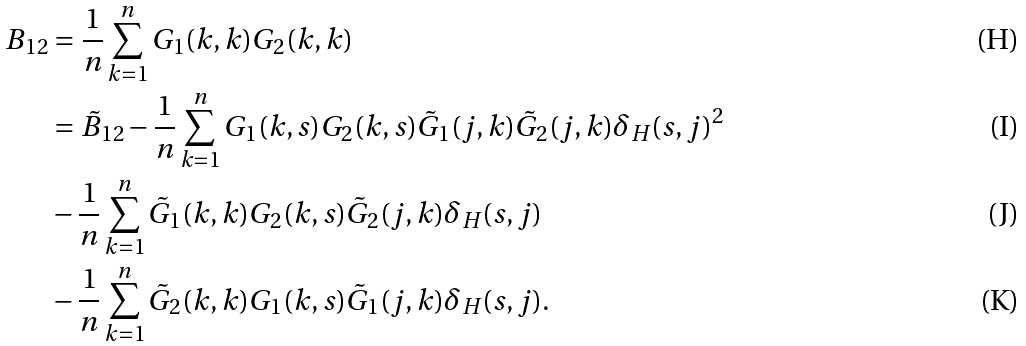Convert formula to latex. <formula><loc_0><loc_0><loc_500><loc_500>B _ { 1 2 } & = \frac { 1 } { n } \sum _ { k = 1 } ^ { n } G _ { 1 } ( k , k ) G _ { 2 } ( k , k ) \\ & = \tilde { B } _ { 1 2 } - \frac { 1 } { n } \sum _ { k = 1 } ^ { n } G _ { 1 } ( k , s ) G _ { 2 } ( k , s ) \tilde { G } _ { 1 } ( j , k ) \tilde { G } _ { 2 } ( j , k ) \delta _ { H } ( s , j ) ^ { 2 } \\ & - \frac { 1 } { n } \sum _ { k = 1 } ^ { n } \tilde { G } _ { 1 } ( k , k ) G _ { 2 } ( k , s ) \tilde { G } _ { 2 } ( j , k ) \delta _ { H } ( s , j ) \\ & - \frac { 1 } { n } \sum _ { k = 1 } ^ { n } \tilde { G } _ { 2 } ( k , k ) G _ { 1 } ( k , s ) \tilde { G } _ { 1 } ( j , k ) \delta _ { H } ( s , j ) .</formula> 